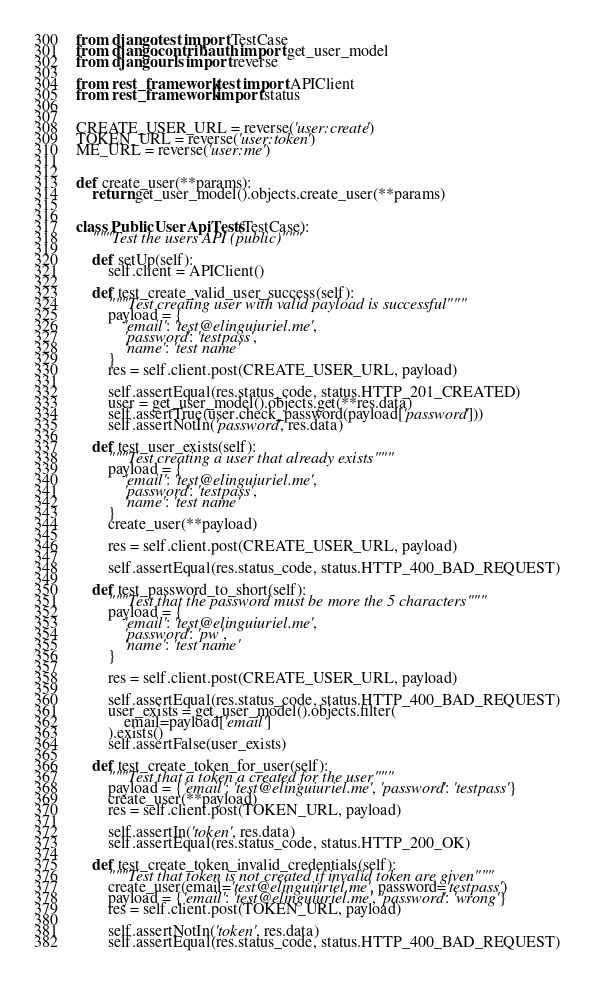Convert code to text. <code><loc_0><loc_0><loc_500><loc_500><_Python_>from django.test import TestCase
from django.contrib.auth import get_user_model
from django.urls import reverse

from rest_framework.test import APIClient
from rest_framework import status


CREATE_USER_URL = reverse('user:create')
TOKEN_URL = reverse('user:token')
ME_URL = reverse('user:me')


def create_user(**params):
    return get_user_model().objects.create_user(**params)


class PublicUserApiTests(TestCase):
    """Test the users API (public)"""

    def setUp(self):
        self.client = APIClient()

    def test_create_valid_user_success(self):
        """Test creating user with valid payload is successful"""
        payload = {
            'email': 'test@elinguiuriel.me',
            'password': 'testpass',
            'name': 'test name'
        }
        res = self.client.post(CREATE_USER_URL, payload)

        self.assertEqual(res.status_code, status.HTTP_201_CREATED)
        user = get_user_model().objects.get(**res.data)
        self.assertTrue(user.check_password(payload['password']))
        self.assertNotIn('password', res.data)

    def test_user_exists(self):
        """Test creating a user that already exists"""
        payload = {
            'email': 'test@elinguiuriel.me',
            'password': 'testpass',
            'name': 'test name'
        }
        create_user(**payload)

        res = self.client.post(CREATE_USER_URL, payload)

        self.assertEqual(res.status_code, status.HTTP_400_BAD_REQUEST)

    def test_password_to_short(self):
        """Test that the password must be more the 5 characters"""
        payload = {
            'email': 'test@elinguiuriel.me',
            'password': 'pw',
            'name': 'test name'
        }

        res = self.client.post(CREATE_USER_URL, payload)

        self.assertEqual(res.status_code, status.HTTP_400_BAD_REQUEST)
        user_exists = get_user_model().objects.filter(
            email=payload['email']
        ).exists()
        self.assertFalse(user_exists)

    def test_create_token_for_user(self):
        """Test that a token a created for the user"""
        payload = {'email': 'test@elinguiuriel.me', 'password': 'testpass'}
        create_user(**payload)
        res = self.client.post(TOKEN_URL, payload)

        self.assertIn('token', res.data)
        self.assertEqual(res.status_code, status.HTTP_200_OK)

    def test_create_token_invalid_credentials(self):
        """Test that token is not created if invalid token are given"""
        create_user(email='test@elinguiuriel.me', password='testpass')
        payload = {'email': 'test@elinguiuriel.me', 'password': 'wrong'}
        res = self.client.post(TOKEN_URL, payload)

        self.assertNotIn('token', res.data)
        self.assertEqual(res.status_code, status.HTTP_400_BAD_REQUEST)
</code> 